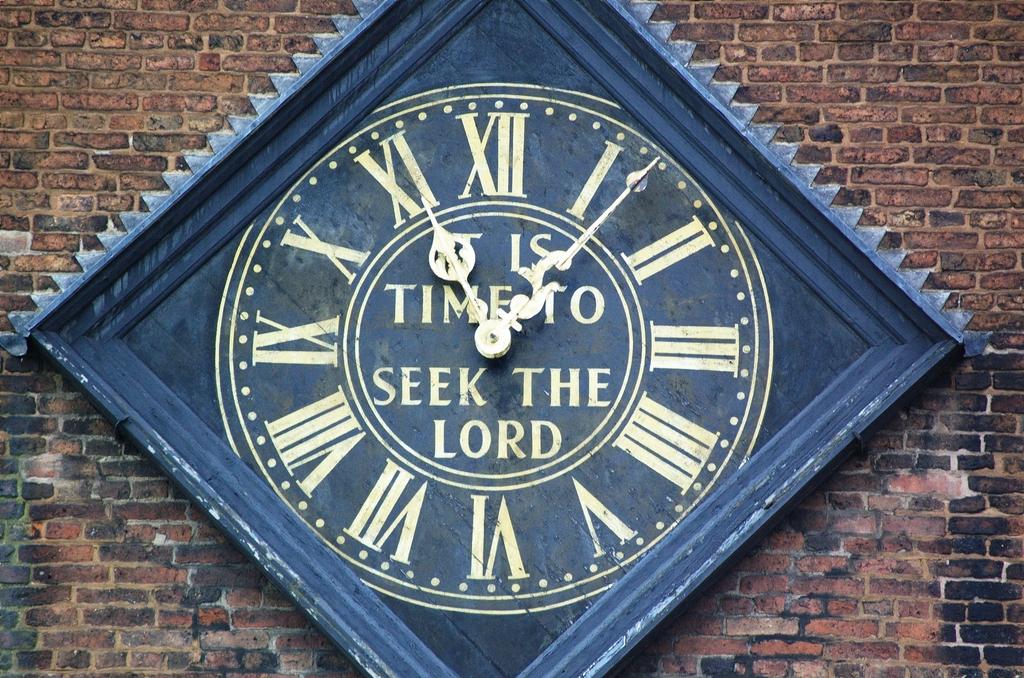Based on the clock's words, what time is it?
Provide a short and direct response. Time to seek the lord. 